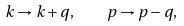<formula> <loc_0><loc_0><loc_500><loc_500>k \to k + q , \quad p \to p - q ,</formula> 